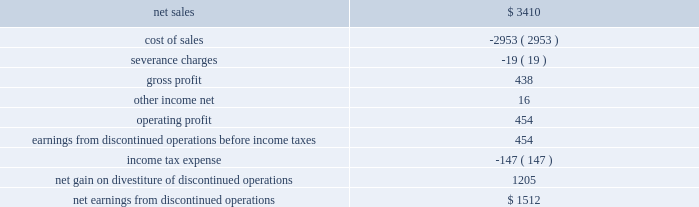As a result of the transaction , we recognized a net gain of approximately $ 1.3 billion , including $ 1.2 billion recognized in 2016 .
The net gain represents the $ 2.5 billion fair value of the shares of lockheed martin common stock exchanged and retired as part of the exchange offer , plus the $ 1.8 billion one-time special cash payment , less the net book value of the is&gs business of about $ 3.0 billion at august 16 , 2016 and other adjustments of about $ 100 million .
In 2017 , we recognized an additional gain of $ 73 million , which reflects certain post-closing adjustments , including certain tax adjustments and the final determination of net working capital .
We classified the operating results of our former is&gs business as discontinued operations in our consolidated financial statements in accordance with u.s .
Gaap , as the divestiture of this business represented a strategic shift that had a major effect on our operations and financial results .
However , the cash flows generated by the is&gs business have not been reclassified in our consolidated statements of cash flows as we retained this cash as part of the transaction .
The operating results , prior to the august 16 , 2016 divestiture date , of the is&gs business that have been reflected within net earnings from discontinued operations for the year ended december 31 , 2016 are as follows ( in millions ) : .
The operating results of the is&gs business reported as discontinued operations are different than the results previously reported for the is&gs business segment .
Results reported within net earnings from discontinued operations only include costs that were directly attributable to the is&gs business and exclude certain corporate overhead costs that were previously allocated to the is&gs business .
As a result , we reclassified $ 82 million in 2016 of corporate overhead costs from the is&gs business to other unallocated , net on our consolidated statement of earnings .
Additionally , we retained all assets and obligations related to the pension benefits earned by former is&gs business salaried employees through the date of divestiture .
Therefore , the non-service portion of net pension costs ( e.g. , interest cost , actuarial gains and losses and expected return on plan assets ) for these plans have been reclassified from the operating results of the is&gs business segment and reported as a reduction to the fas/cas pension adjustment .
These net pension costs were $ 54 million for the year ended december 31 , 2016 .
The service portion of net pension costs related to is&gs business 2019s salaried employees that transferred to leidos were included in the operating results of the is&gs business classified as discontinued operations because such costs are no longer incurred by us .
Significant severance charges related to the is&gs business were historically recorded at the lockheed martin corporate office .
These charges have been reclassified into the operating results of the is&gs business , classified as discontinued operations , and excluded from the operating results of our continuing operations .
The amount of severance charges reclassified were $ 19 million in 2016 .
Financial information related to cash flows generated by the is&gs business , such as depreciation and amortization , capital expenditures , and other non-cash items , included in our consolidated statement of cash flows for the years ended december 31 , 2016 were not significant. .
What was the profit margin in december 2016? 
Computations: (454 / 3410)
Answer: 0.13314. As a result of the transaction , we recognized a net gain of approximately $ 1.3 billion , including $ 1.2 billion recognized in 2016 .
The net gain represents the $ 2.5 billion fair value of the shares of lockheed martin common stock exchanged and retired as part of the exchange offer , plus the $ 1.8 billion one-time special cash payment , less the net book value of the is&gs business of about $ 3.0 billion at august 16 , 2016 and other adjustments of about $ 100 million .
In 2017 , we recognized an additional gain of $ 73 million , which reflects certain post-closing adjustments , including certain tax adjustments and the final determination of net working capital .
We classified the operating results of our former is&gs business as discontinued operations in our consolidated financial statements in accordance with u.s .
Gaap , as the divestiture of this business represented a strategic shift that had a major effect on our operations and financial results .
However , the cash flows generated by the is&gs business have not been reclassified in our consolidated statements of cash flows as we retained this cash as part of the transaction .
The operating results , prior to the august 16 , 2016 divestiture date , of the is&gs business that have been reflected within net earnings from discontinued operations for the year ended december 31 , 2016 are as follows ( in millions ) : .
The operating results of the is&gs business reported as discontinued operations are different than the results previously reported for the is&gs business segment .
Results reported within net earnings from discontinued operations only include costs that were directly attributable to the is&gs business and exclude certain corporate overhead costs that were previously allocated to the is&gs business .
As a result , we reclassified $ 82 million in 2016 of corporate overhead costs from the is&gs business to other unallocated , net on our consolidated statement of earnings .
Additionally , we retained all assets and obligations related to the pension benefits earned by former is&gs business salaried employees through the date of divestiture .
Therefore , the non-service portion of net pension costs ( e.g. , interest cost , actuarial gains and losses and expected return on plan assets ) for these plans have been reclassified from the operating results of the is&gs business segment and reported as a reduction to the fas/cas pension adjustment .
These net pension costs were $ 54 million for the year ended december 31 , 2016 .
The service portion of net pension costs related to is&gs business 2019s salaried employees that transferred to leidos were included in the operating results of the is&gs business classified as discontinued operations because such costs are no longer incurred by us .
Significant severance charges related to the is&gs business were historically recorded at the lockheed martin corporate office .
These charges have been reclassified into the operating results of the is&gs business , classified as discontinued operations , and excluded from the operating results of our continuing operations .
The amount of severance charges reclassified were $ 19 million in 2016 .
Financial information related to cash flows generated by the is&gs business , such as depreciation and amortization , capital expenditures , and other non-cash items , included in our consolidated statement of cash flows for the years ended december 31 , 2016 were not significant. .
What is the operating profit margin? 
Computations: (454 / 3410)
Answer: 0.13314. 